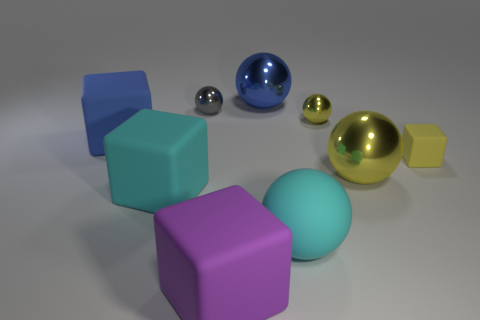Subtract all tiny shiny balls. How many balls are left? 3 Add 1 small red metallic cubes. How many objects exist? 10 Subtract all balls. How many objects are left? 4 Subtract 1 spheres. How many spheres are left? 4 Subtract all cyan cubes. How many cubes are left? 3 Subtract 0 red cubes. How many objects are left? 9 Subtract all brown spheres. Subtract all green cylinders. How many spheres are left? 5 Subtract all gray cylinders. How many yellow balls are left? 2 Subtract all rubber things. Subtract all small gray spheres. How many objects are left? 3 Add 9 tiny blocks. How many tiny blocks are left? 10 